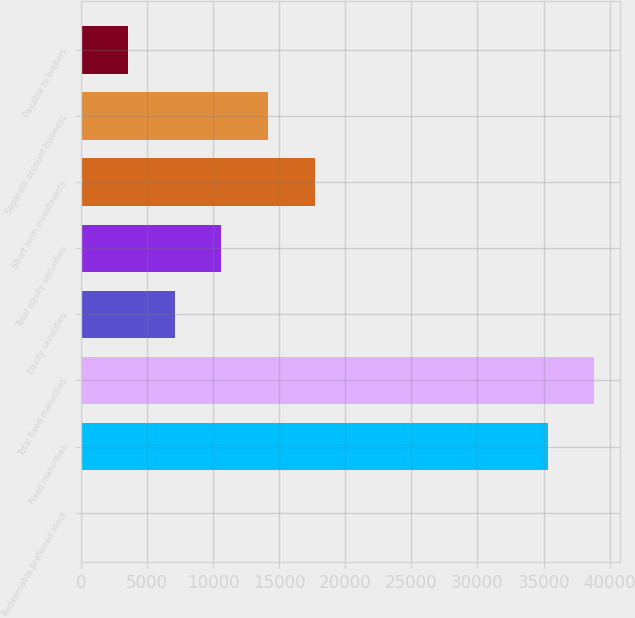Convert chart. <chart><loc_0><loc_0><loc_500><loc_500><bar_chart><fcel>Redeemable preferred stock<fcel>Fixed maturities<fcel>Total fixed maturities<fcel>Equity securities<fcel>Total equity securities<fcel>Short term investments<fcel>Separate account business<fcel>Payable to brokers<nl><fcel>48<fcel>35297<fcel>38826.6<fcel>7107.2<fcel>10636.8<fcel>17696<fcel>14166.4<fcel>3577.6<nl></chart> 